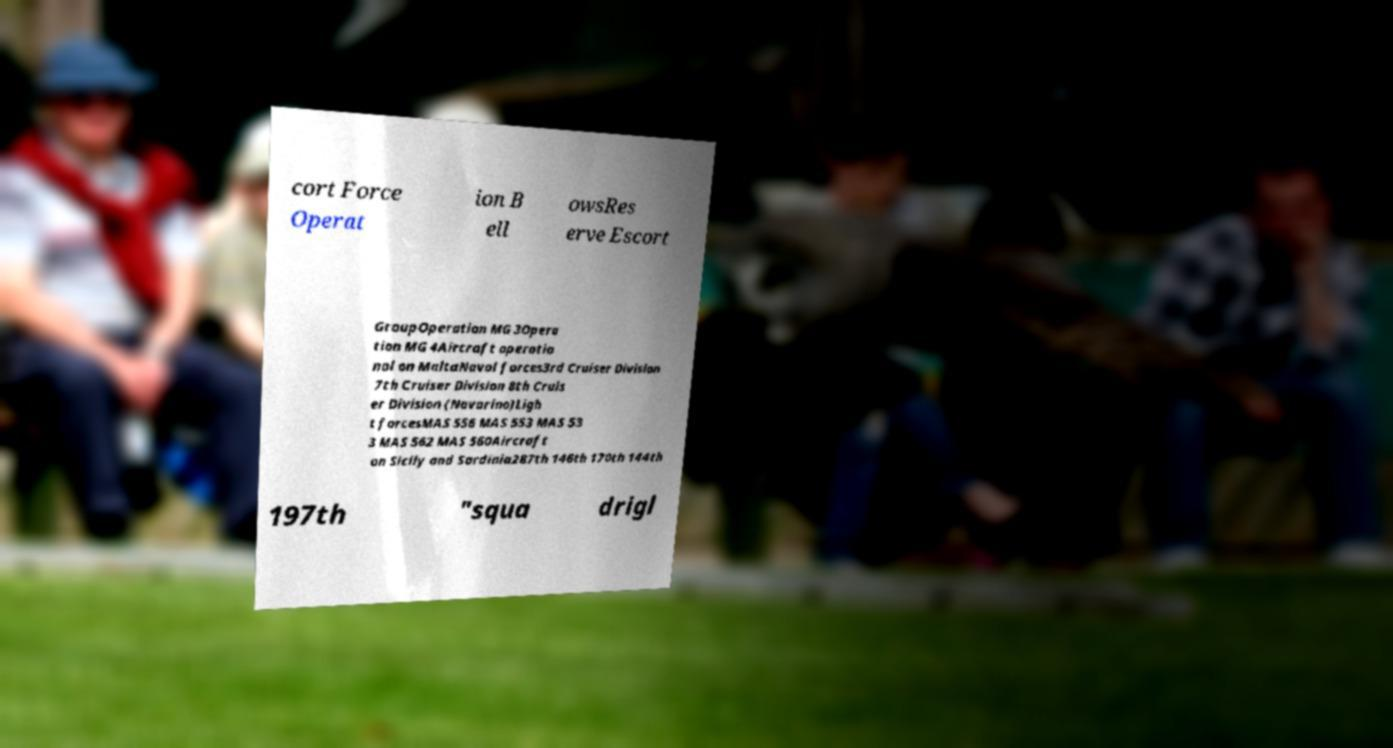Please identify and transcribe the text found in this image. cort Force Operat ion B ell owsRes erve Escort GroupOperation MG 3Opera tion MG 4Aircraft operatio nal on MaltaNaval forces3rd Cruiser Division 7th Cruiser Division 8th Cruis er Division (Navarino)Ligh t forcesMAS 556 MAS 553 MAS 53 3 MAS 562 MAS 560Aircraft on Sicily and Sardinia287th 146th 170th 144th 197th "squa drigl 